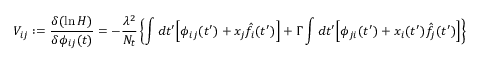<formula> <loc_0><loc_0><loc_500><loc_500>V _ { i j } \colon = \frac { \delta ( \ln H ) } { \delta \phi _ { i j } ( t ) } = - \frac { \lambda ^ { 2 } } { N _ { t } } \left \{ \int d t ^ { \prime } \left [ \phi _ { i j } ( t ^ { \prime } ) + x _ { j } \hat { f } _ { i } ( t ^ { \prime } ) \right ] + \Gamma \int d t ^ { \prime } \left [ \phi _ { j i } ( t ^ { \prime } ) + x _ { i } ( t ^ { \prime } ) \hat { f } _ { j } ( t ^ { \prime } ) \right ] \right \}</formula> 